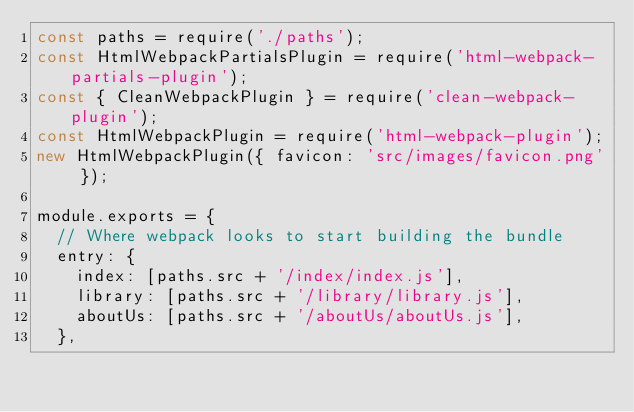<code> <loc_0><loc_0><loc_500><loc_500><_JavaScript_>const paths = require('./paths');
const HtmlWebpackPartialsPlugin = require('html-webpack-partials-plugin');
const { CleanWebpackPlugin } = require('clean-webpack-plugin');
const HtmlWebpackPlugin = require('html-webpack-plugin');
new HtmlWebpackPlugin({ favicon: 'src/images/favicon.png' });

module.exports = {
  // Where webpack looks to start building the bundle
  entry: {
    index: [paths.src + '/index/index.js'],
    library: [paths.src + '/library/library.js'],
    aboutUs: [paths.src + '/aboutUs/aboutUs.js'],
  },</code> 